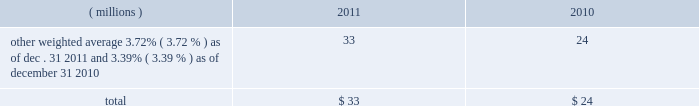Notes to the consolidated financial statements at a price equal to 101% ( 101 % ) of their principal amount plus accrued and unpaid interest .
Cash proceeds from the sale of these notes was $ 983 million ( net of discount and issuance costs ) .
The discount and issuance costs related to these notes , which totaled $ 17 million , will be amortized to interest expense over the respective terms of the notes .
In august 2010 , ppg entered into a three-year credit agreement with several banks and financial institutions ( the 201ccredit agreement 201d ) .
The credit agreement provides for a $ 1.2 billion unsecured revolving credit facility .
In connection with entering into this credit agreement , the company terminated its 20ac650 million and its $ 1 billion revolving credit facilities that were each set to expire in 2011 .
There were no outstanding amounts due under either revolving facility at the times of their termination .
The company has the ability to increase the size of the credit agreement by up to an additional $ 300 million , subject to the receipt of lender commitments and other conditions .
The credit agreement will terminate and all amounts outstanding will be due and payable on august 5 , 2013 .
The credit agreement provides that loans will bear interest at rates based , at the company 2019s option , on one of two specified base rates plus a margin based on certain formulas defined in the credit agreement .
Additionally , the credit agreement contains a commitment fee on the amount of unused commitment under the credit agreement ranging from 0.125% ( 0.125 % ) to 0.625% ( 0.625 % ) per annum .
The applicable interest rate and the fee will vary depending on the ratings established by standard & poor 2019s financial services llc and moody 2019s investor service inc .
For the company 2019s non-credit enhanced , long- term , senior , unsecured debt .
There were no amounts outstanding under the credit agreement at december 31 , 2011 ; however , the available borrowing rate on a one month , u.s .
Dollar denominated borrowing would have been 1.05 percent .
The credit agreement contains usual and customary restrictive covenants for facilities of its type , which include , with specified exceptions , limitations on the company 2019s ability to create liens or other encumbrances , to enter into sale and leaseback transactions and to enter into consolidations , mergers or transfers of all or substantially all of its assets .
The credit agreement also requires the company to maintain a ratio of total indebtedness to total capitalization , as defined in the credit agreement , of 60 percent or less .
The credit agreement contains customary events of default that would permit the lenders to accelerate the repayment of any loans , including the failure to make timely payments when due under the credit agreement or other material indebtedness , the failure to satisfy covenants contained in the credit agreement , a change in control of the company and specified events of bankruptcy and insolvency .
Ppg 2019s non-u.s .
Operations have uncommitted lines of credit totaling $ 679 million of which $ 36 million was used as of december 31 , 2011 .
These uncommitted lines of credit are subject to cancellation at any time and are generally not subject to any commitment fees .
Short-term debt outstanding as of december 31 , 2011 and 2010 , was as follows : ( millions ) 2011 2010 other , weighted average 3.72% ( 3.72 % ) as of dec .
31 , 2011 and 3.39% ( 3.39 % ) as of december 31 , 2010 33 24 total $ 33 $ 24 ppg is in compliance with the restrictive covenants under its various credit agreements , loan agreements and indentures .
The company 2019s revolving credit agreements include a financial ratio covenant .
The covenant requires that the amount of total indebtedness not exceed 60% ( 60 % ) of the company 2019s total capitalization excluding the portion of accumulated other comprehensive income ( loss ) related to pensions and other postretirement benefit adjustments .
As of december 31 , 2011 , total indebtedness was 43 percent of the company 2019s total capitalization excluding the portion of accumulated other comprehensive income ( loss ) related to pensions and other postretirement benefit adjustments .
Additionally , substantially all of the company 2019s debt agreements contain customary cross-default provisions .
Those provisions generally provide that a default on a debt service payment of $ 10 million or more for longer than the grace period provided ( usually 10 days ) under one agreement may result in an event of default under other agreements .
None of the company 2019s primary debt obligations are secured or guaranteed by the company 2019s affiliates .
Interest payments in 2011 , 2010 and 2009 totaled $ 212 million , $ 189 million and $ 201 million , respectively .
In october 2009 , the company entered into an agreement with a counterparty to repurchase up to 1.2 million shares of the company 2019s stock of which 1.1 million shares were purchased in the open market ( 465006 of these shares were purchased as of december 31 , 2009 at a weighted average price of $ 56.66 per share ) .
The counterparty held the shares until september of 2010 when the company paid $ 65 million and took possession of these shares .
In december 2008 , the company entered into an agreement with a counterparty to repurchase 1.5 million 44 2011 ppg annual report and form 10-k .
Notes to the consolidated financial statements at a price equal to 101% ( 101 % ) of their principal amount plus accrued and unpaid interest .
Cash proceeds from the sale of these notes was $ 983 million ( net of discount and issuance costs ) .
The discount and issuance costs related to these notes , which totaled $ 17 million , will be amortized to interest expense over the respective terms of the notes .
In august 2010 , ppg entered into a three-year credit agreement with several banks and financial institutions ( the 201ccredit agreement 201d ) .
The credit agreement provides for a $ 1.2 billion unsecured revolving credit facility .
In connection with entering into this credit agreement , the company terminated its 20ac650 million and its $ 1 billion revolving credit facilities that were each set to expire in 2011 .
There were no outstanding amounts due under either revolving facility at the times of their termination .
The company has the ability to increase the size of the credit agreement by up to an additional $ 300 million , subject to the receipt of lender commitments and other conditions .
The credit agreement will terminate and all amounts outstanding will be due and payable on august 5 , 2013 .
The credit agreement provides that loans will bear interest at rates based , at the company 2019s option , on one of two specified base rates plus a margin based on certain formulas defined in the credit agreement .
Additionally , the credit agreement contains a commitment fee on the amount of unused commitment under the credit agreement ranging from 0.125% ( 0.125 % ) to 0.625% ( 0.625 % ) per annum .
The applicable interest rate and the fee will vary depending on the ratings established by standard & poor 2019s financial services llc and moody 2019s investor service inc .
For the company 2019s non-credit enhanced , long- term , senior , unsecured debt .
There were no amounts outstanding under the credit agreement at december 31 , 2011 ; however , the available borrowing rate on a one month , u.s .
Dollar denominated borrowing would have been 1.05 percent .
The credit agreement contains usual and customary restrictive covenants for facilities of its type , which include , with specified exceptions , limitations on the company 2019s ability to create liens or other encumbrances , to enter into sale and leaseback transactions and to enter into consolidations , mergers or transfers of all or substantially all of its assets .
The credit agreement also requires the company to maintain a ratio of total indebtedness to total capitalization , as defined in the credit agreement , of 60 percent or less .
The credit agreement contains customary events of default that would permit the lenders to accelerate the repayment of any loans , including the failure to make timely payments when due under the credit agreement or other material indebtedness , the failure to satisfy covenants contained in the credit agreement , a change in control of the company and specified events of bankruptcy and insolvency .
Ppg 2019s non-u.s .
Operations have uncommitted lines of credit totaling $ 679 million of which $ 36 million was used as of december 31 , 2011 .
These uncommitted lines of credit are subject to cancellation at any time and are generally not subject to any commitment fees .
Short-term debt outstanding as of december 31 , 2011 and 2010 , was as follows : ( millions ) 2011 2010 other , weighted average 3.72% ( 3.72 % ) as of dec .
31 , 2011 and 3.39% ( 3.39 % ) as of december 31 , 2010 33 24 total $ 33 $ 24 ppg is in compliance with the restrictive covenants under its various credit agreements , loan agreements and indentures .
The company 2019s revolving credit agreements include a financial ratio covenant .
The covenant requires that the amount of total indebtedness not exceed 60% ( 60 % ) of the company 2019s total capitalization excluding the portion of accumulated other comprehensive income ( loss ) related to pensions and other postretirement benefit adjustments .
As of december 31 , 2011 , total indebtedness was 43 percent of the company 2019s total capitalization excluding the portion of accumulated other comprehensive income ( loss ) related to pensions and other postretirement benefit adjustments .
Additionally , substantially all of the company 2019s debt agreements contain customary cross-default provisions .
Those provisions generally provide that a default on a debt service payment of $ 10 million or more for longer than the grace period provided ( usually 10 days ) under one agreement may result in an event of default under other agreements .
None of the company 2019s primary debt obligations are secured or guaranteed by the company 2019s affiliates .
Interest payments in 2011 , 2010 and 2009 totaled $ 212 million , $ 189 million and $ 201 million , respectively .
In october 2009 , the company entered into an agreement with a counterparty to repurchase up to 1.2 million shares of the company 2019s stock of which 1.1 million shares were purchased in the open market ( 465006 of these shares were purchased as of december 31 , 2009 at a weighted average price of $ 56.66 per share ) .
The counterparty held the shares until september of 2010 when the company paid $ 65 million and took possession of these shares .
In december 2008 , the company entered into an agreement with a counterparty to repurchase 1.5 million 44 2011 ppg annual report and form 10-k .
What was the percentage change in total interest payments from 2009 to 2010? 
Computations: ((189 - 201) / 201)
Answer: -0.0597. 